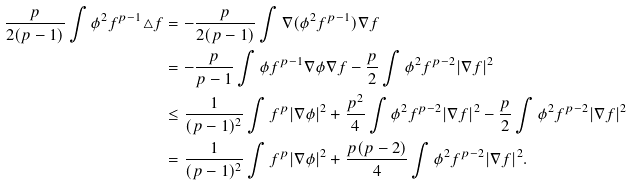Convert formula to latex. <formula><loc_0><loc_0><loc_500><loc_500>\frac { p } { 2 ( p - 1 ) } \int \phi ^ { 2 } f ^ { p - 1 } \triangle f & = - \frac { p } { 2 ( p - 1 ) } \int \nabla ( \phi ^ { 2 } f ^ { p - 1 } ) \nabla f \\ & = - \frac { p } { p - 1 } \int \phi f ^ { p - 1 } \nabla \phi \nabla f - \frac { p } { 2 } \int \phi ^ { 2 } f ^ { p - 2 } | \nabla f | ^ { 2 } \\ & \leq \frac { 1 } { ( p - 1 ) ^ { 2 } } \int f ^ { p } | \nabla \phi | ^ { 2 } + \frac { p ^ { 2 } } { 4 } \int \phi ^ { 2 } f ^ { p - 2 } | \nabla f | ^ { 2 } - \frac { p } { 2 } \int \phi ^ { 2 } f ^ { p - 2 } | \nabla f | ^ { 2 } \\ & = \frac { 1 } { ( p - 1 ) ^ { 2 } } \int f ^ { p } | \nabla \phi | ^ { 2 } + \frac { p ( p - 2 ) } { 4 } \int \phi ^ { 2 } f ^ { p - 2 } | \nabla f | ^ { 2 } .</formula> 